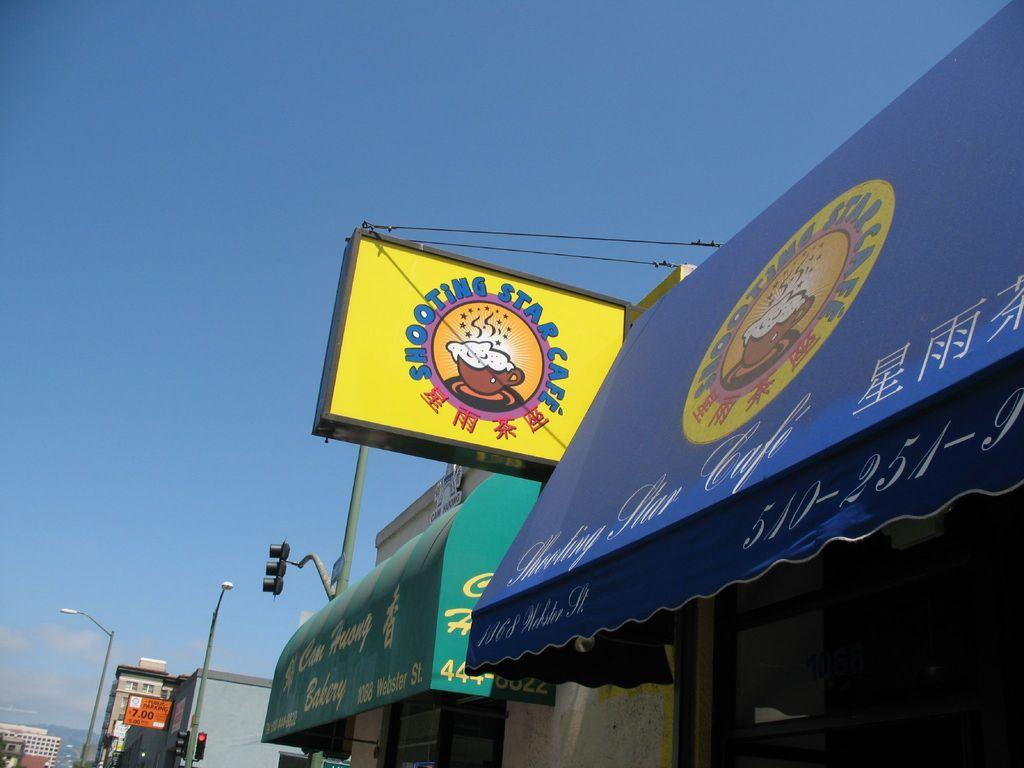Provide a one-sentence caption for the provided image. The sign for the shooting star cafe has English and Asian script on the sign. 